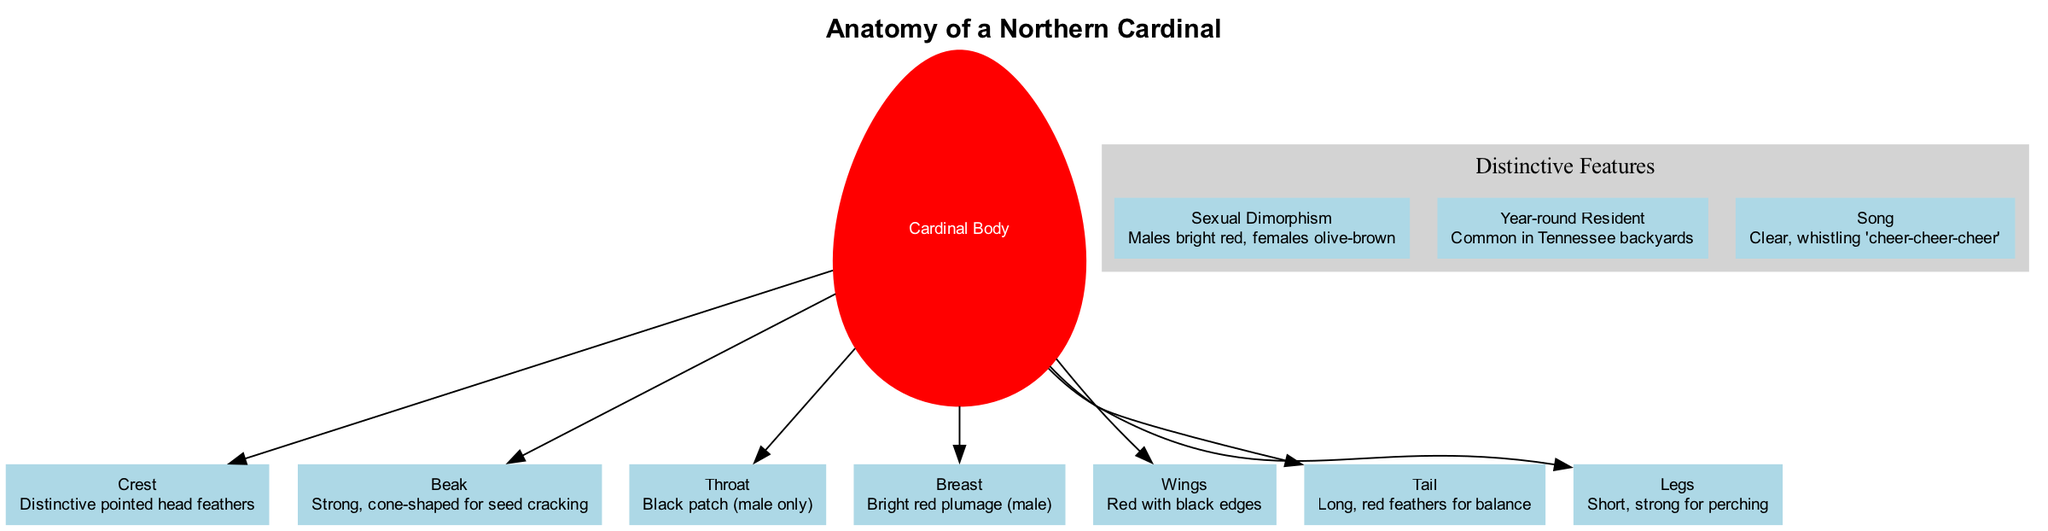What is the distinctive feature that describes the male Northern Cardinal? The diagram states that males have "bright red" plumage, distinguishing them from females. This is the primary characteristic noted under sexual dimorphism.
Answer: bright red How many parts are labeled on the diagram? There are seven parts listed in the diagram, which are all connected to the main body node labeled "Cardinal Body."
Answer: 7 What does the beak of the Northern Cardinal look like? The beak is described as "Strong, cone-shaped for seed cracking," indicating its function and shape directly in the diagram.
Answer: Strong, cone-shaped Which part of the Northern Cardinal is described as having a black patch in males? The diagram specifically labels the "Throat" as having a "black patch (male only)," indicating this distinct feature in male cardinals.
Answer: Throat What is the song of the Northern Cardinal? The song is described as a "Clear, whistling 'cheer-cheer-cheer,'" giving a specific description of the vocalization attributed to this bird.
Answer: Clear, whistling 'cheer-cheer-cheer' Which part is described as being long and red? The "Tail" is identified as having "Long, red feathers for balance," conveying its size and purpose.
Answer: Tail What color are the wings of the male Northern Cardinal? The wings are described as "Red with black edges," which specifies the color and detailing on the wings.
Answer: Red with black edges What does 'Year-round Resident' imply about the Northern Cardinal in Tennessee? This distinctive feature indicates that Northern Cardinals are commonly found throughout the year in Tennessee, as stated in the diagram.
Answer: Common in Tennessee backyards 